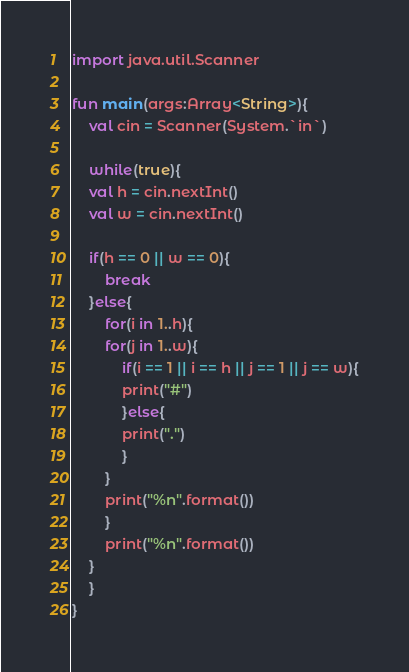Convert code to text. <code><loc_0><loc_0><loc_500><loc_500><_Kotlin_>import java.util.Scanner

fun main(args:Array<String>){
    val cin = Scanner(System.`in`)

    while(true){
	val h = cin.nextInt()
	val w = cin.nextInt()
	
	if(h == 0 || w == 0){
	    break
	}else{
	    for(i in 1..h){
		for(j in 1..w){
		    if(i == 1 || i == h || j == 1 || j == w){
			print("#")
		    }else{
			print(".")
		    }
		}
		print("%n".format())
	    }
	    print("%n".format())
	}
    }
}

</code> 